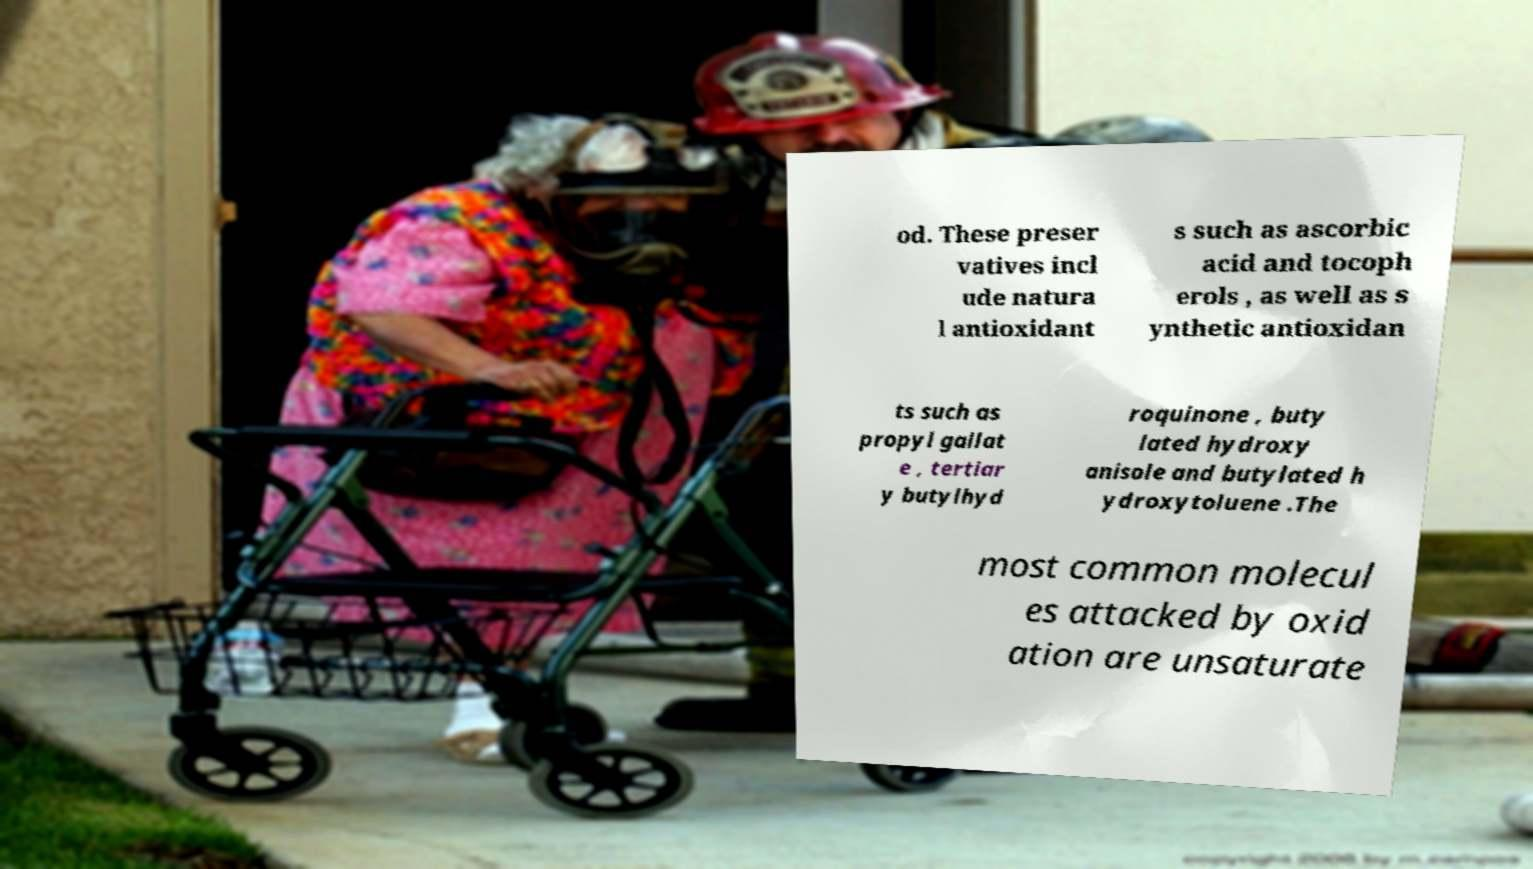Can you accurately transcribe the text from the provided image for me? od. These preser vatives incl ude natura l antioxidant s such as ascorbic acid and tocoph erols , as well as s ynthetic antioxidan ts such as propyl gallat e , tertiar y butylhyd roquinone , buty lated hydroxy anisole and butylated h ydroxytoluene .The most common molecul es attacked by oxid ation are unsaturate 